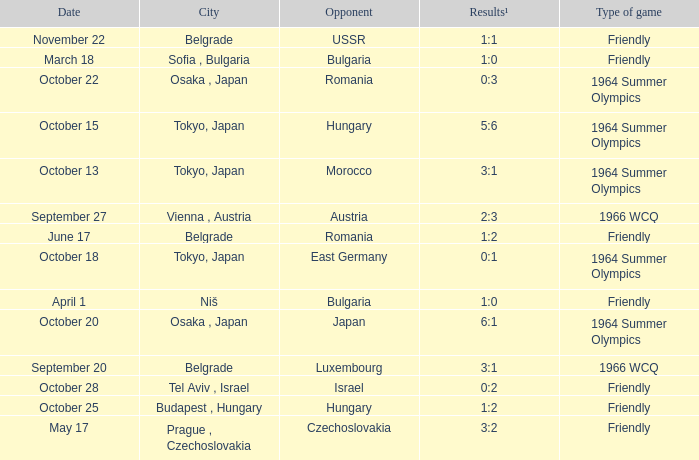What day were the results 3:2? May 17. 